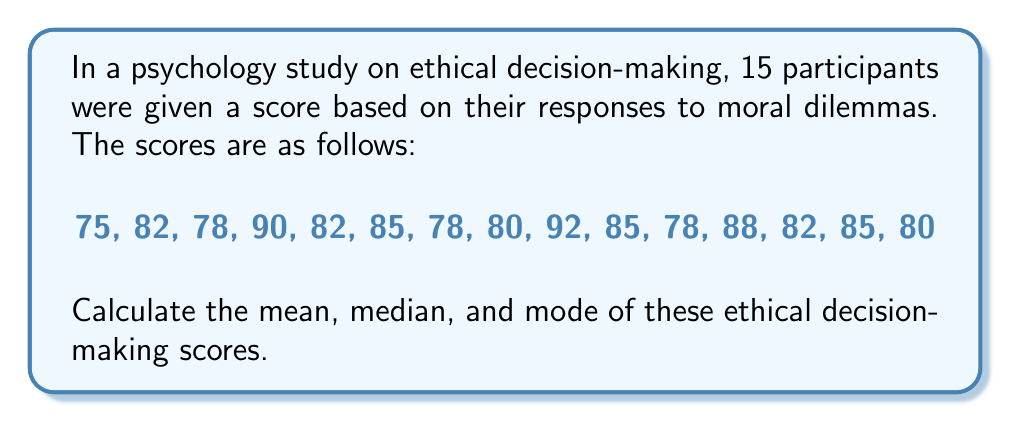Could you help me with this problem? 1. Calculate the mean:
   a. Sum all the scores:
      $75 + 82 + 78 + 90 + 82 + 85 + 78 + 80 + 92 + 85 + 78 + 88 + 82 + 85 + 80 = 1240$
   b. Divide the sum by the number of scores (15):
      $\text{Mean} = \frac{1240}{15} = 82.67$

2. Find the median:
   a. Arrange the scores in ascending order:
      75, 78, 78, 78, 80, 80, 82, 82, 82, 85, 85, 85, 88, 90, 92
   b. With 15 scores, the median is the 8th score (middle value):
      $\text{Median} = 82$

3. Determine the mode:
   a. Identify the most frequently occurring score(s):
      78 appears 3 times
      82 appears 3 times
      85 appears 3 times
   b. Since there are multiple scores that appear with the highest frequency, we have a multimodal distribution.

Therefore, the mean is 82.67, the median is 82, and the mode is multimodal with values 78, 82, and 85.
Answer: Mean: 82.67, Median: 82, Mode: 78, 82, 85 (multimodal) 